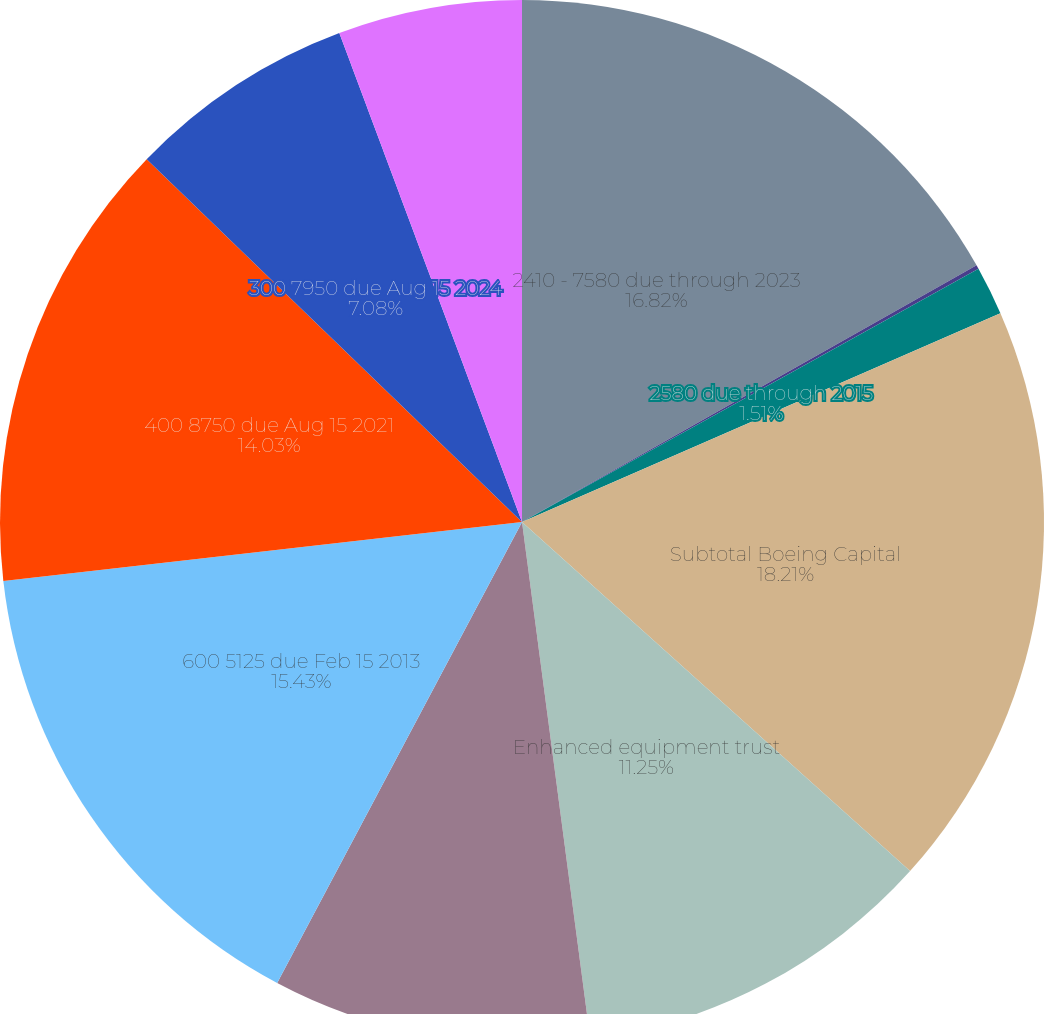Convert chart. <chart><loc_0><loc_0><loc_500><loc_500><pie_chart><fcel>2410 - 7580 due through 2023<fcel>3010 - 5790 notes due through<fcel>2580 due through 2015<fcel>Subtotal Boeing Capital<fcel>Enhanced equipment trust<fcel>350 9750 due Apr 1 2012<fcel>600 5125 due Feb 15 2013<fcel>400 8750 due Aug 15 2021<fcel>300 7950 due Aug 15 2024<fcel>250 7250 due Jun 15 2025<nl><fcel>16.82%<fcel>0.12%<fcel>1.51%<fcel>18.21%<fcel>11.25%<fcel>9.86%<fcel>15.43%<fcel>14.03%<fcel>7.08%<fcel>5.69%<nl></chart> 